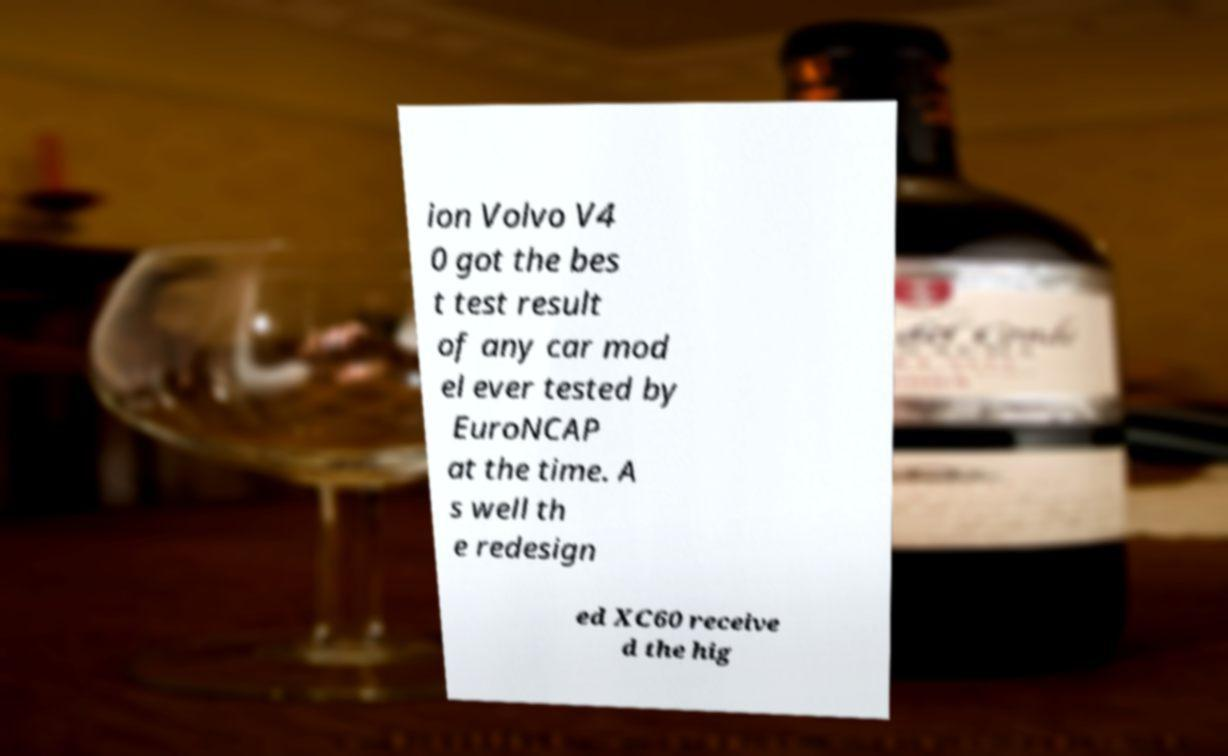Can you read and provide the text displayed in the image?This photo seems to have some interesting text. Can you extract and type it out for me? ion Volvo V4 0 got the bes t test result of any car mod el ever tested by EuroNCAP at the time. A s well th e redesign ed XC60 receive d the hig 